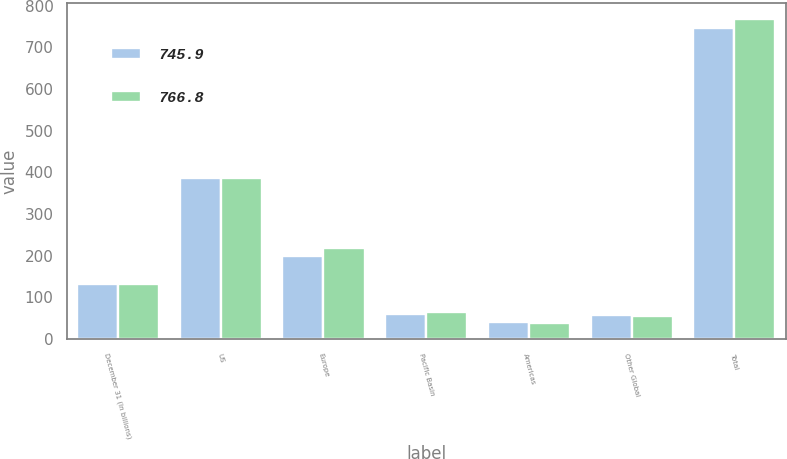<chart> <loc_0><loc_0><loc_500><loc_500><stacked_bar_chart><ecel><fcel>December 31 (In billions)<fcel>US<fcel>Europe<fcel>Pacific Basin<fcel>Americas<fcel>Other Global<fcel>Total<nl><fcel>745.9<fcel>132.5<fcel>387.3<fcel>199.2<fcel>61.1<fcel>40<fcel>58.3<fcel>745.9<nl><fcel>766.8<fcel>132.5<fcel>387.3<fcel>219<fcel>65.8<fcel>38.4<fcel>56.3<fcel>766.8<nl></chart> 